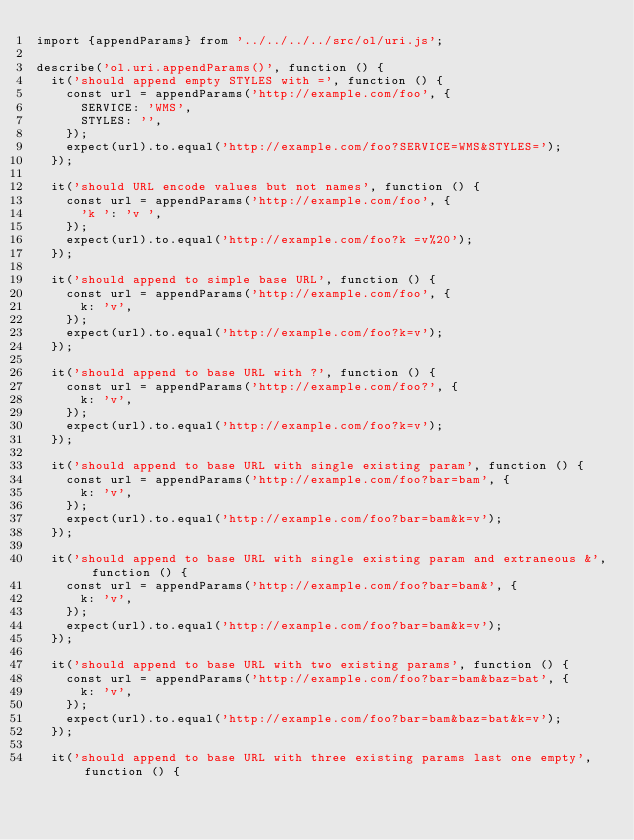Convert code to text. <code><loc_0><loc_0><loc_500><loc_500><_JavaScript_>import {appendParams} from '../../../../src/ol/uri.js';

describe('ol.uri.appendParams()', function () {
  it('should append empty STYLES with =', function () {
    const url = appendParams('http://example.com/foo', {
      SERVICE: 'WMS',
      STYLES: '',
    });
    expect(url).to.equal('http://example.com/foo?SERVICE=WMS&STYLES=');
  });

  it('should URL encode values but not names', function () {
    const url = appendParams('http://example.com/foo', {
      'k ': 'v ',
    });
    expect(url).to.equal('http://example.com/foo?k =v%20');
  });

  it('should append to simple base URL', function () {
    const url = appendParams('http://example.com/foo', {
      k: 'v',
    });
    expect(url).to.equal('http://example.com/foo?k=v');
  });

  it('should append to base URL with ?', function () {
    const url = appendParams('http://example.com/foo?', {
      k: 'v',
    });
    expect(url).to.equal('http://example.com/foo?k=v');
  });

  it('should append to base URL with single existing param', function () {
    const url = appendParams('http://example.com/foo?bar=bam', {
      k: 'v',
    });
    expect(url).to.equal('http://example.com/foo?bar=bam&k=v');
  });

  it('should append to base URL with single existing param and extraneous &', function () {
    const url = appendParams('http://example.com/foo?bar=bam&', {
      k: 'v',
    });
    expect(url).to.equal('http://example.com/foo?bar=bam&k=v');
  });

  it('should append to base URL with two existing params', function () {
    const url = appendParams('http://example.com/foo?bar=bam&baz=bat', {
      k: 'v',
    });
    expect(url).to.equal('http://example.com/foo?bar=bam&baz=bat&k=v');
  });

  it('should append to base URL with three existing params last one empty', function () {</code> 